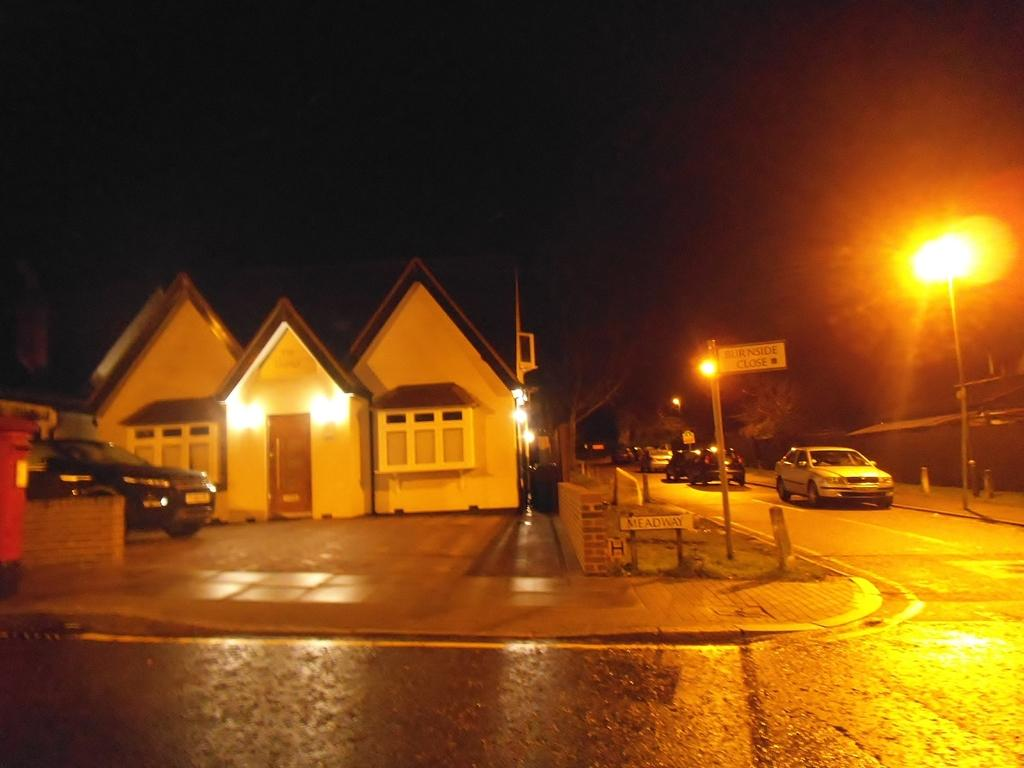What can be seen on the road in the image? There are cars on the road in the image. What type of illumination is visible in the image? There are lights visible in the image. What structures are present in the image? There are poles and name boards in the image. What type of buildings can be seen in the image? There are houses with windows in the image. What type of vegetation is present in the image? There are trees in the image. How would you describe the overall lighting in the image? The background of the image is dark. Can you tell me how many books are on the robin's head in the image? There are no books or robins present in the image. How many rings are visible on the trees in the image? There are no rings visible on the trees in the image. 